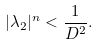Convert formula to latex. <formula><loc_0><loc_0><loc_500><loc_500>| \lambda _ { 2 } | ^ { n } < \frac { 1 } { D ^ { 2 } } .</formula> 